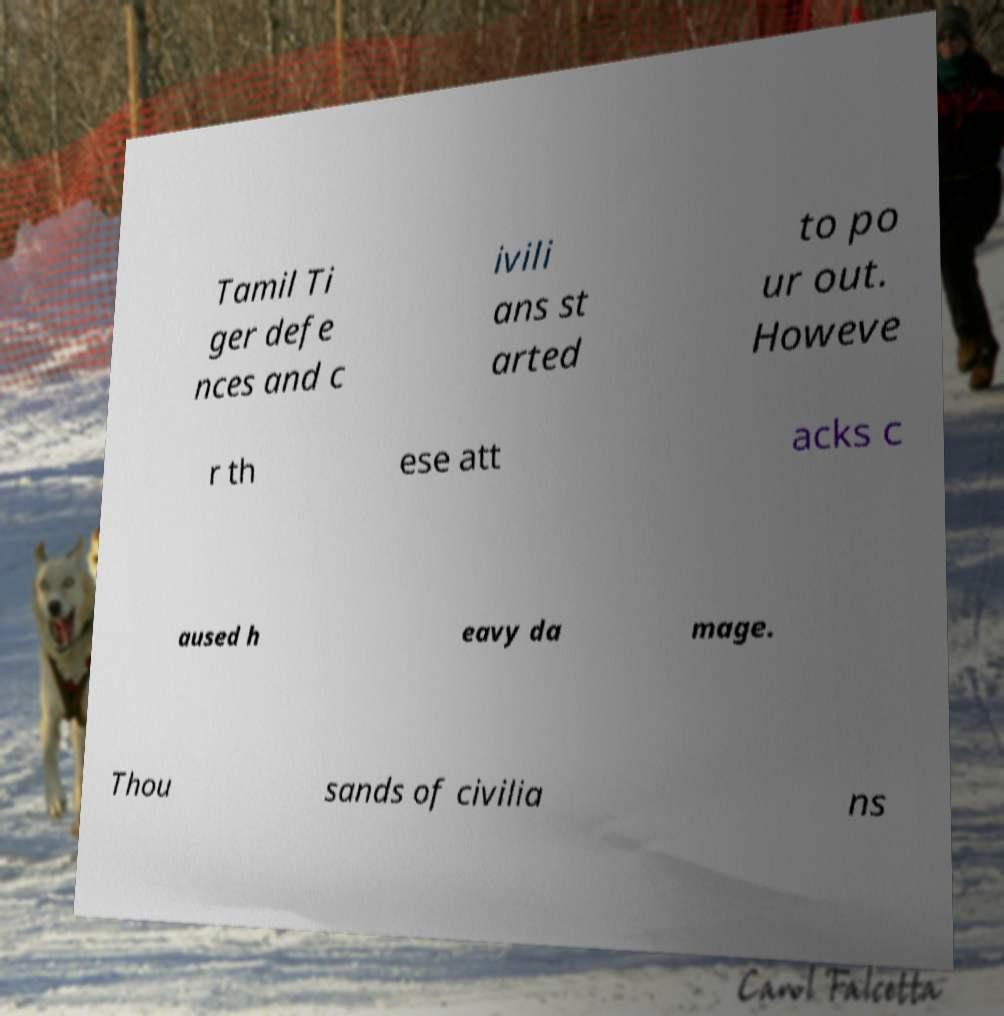I need the written content from this picture converted into text. Can you do that? Tamil Ti ger defe nces and c ivili ans st arted to po ur out. Howeve r th ese att acks c aused h eavy da mage. Thou sands of civilia ns 